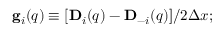Convert formula to latex. <formula><loc_0><loc_0><loc_500><loc_500>\begin{array} { r } { { g } _ { i } ( { q } ) \equiv [ { D } _ { i } ( { q } ) - { D } _ { - i } ( { q } ) ] / 2 \Delta x ; } \end{array}</formula> 